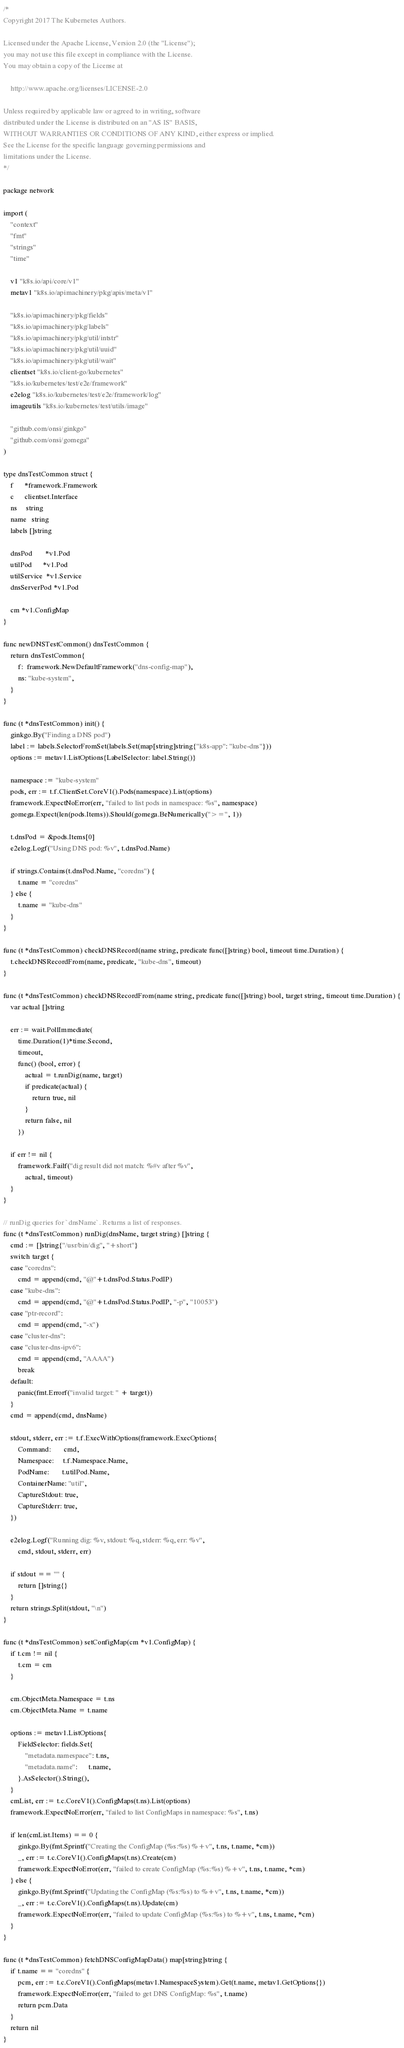Convert code to text. <code><loc_0><loc_0><loc_500><loc_500><_Go_>/*
Copyright 2017 The Kubernetes Authors.

Licensed under the Apache License, Version 2.0 (the "License");
you may not use this file except in compliance with the License.
You may obtain a copy of the License at

    http://www.apache.org/licenses/LICENSE-2.0

Unless required by applicable law or agreed to in writing, software
distributed under the License is distributed on an "AS IS" BASIS,
WITHOUT WARRANTIES OR CONDITIONS OF ANY KIND, either express or implied.
See the License for the specific language governing permissions and
limitations under the License.
*/

package network

import (
	"context"
	"fmt"
	"strings"
	"time"

	v1 "k8s.io/api/core/v1"
	metav1 "k8s.io/apimachinery/pkg/apis/meta/v1"

	"k8s.io/apimachinery/pkg/fields"
	"k8s.io/apimachinery/pkg/labels"
	"k8s.io/apimachinery/pkg/util/intstr"
	"k8s.io/apimachinery/pkg/util/uuid"
	"k8s.io/apimachinery/pkg/util/wait"
	clientset "k8s.io/client-go/kubernetes"
	"k8s.io/kubernetes/test/e2e/framework"
	e2elog "k8s.io/kubernetes/test/e2e/framework/log"
	imageutils "k8s.io/kubernetes/test/utils/image"

	"github.com/onsi/ginkgo"
	"github.com/onsi/gomega"
)

type dnsTestCommon struct {
	f      *framework.Framework
	c      clientset.Interface
	ns     string
	name   string
	labels []string

	dnsPod       *v1.Pod
	utilPod      *v1.Pod
	utilService  *v1.Service
	dnsServerPod *v1.Pod

	cm *v1.ConfigMap
}

func newDNSTestCommon() dnsTestCommon {
	return dnsTestCommon{
		f:  framework.NewDefaultFramework("dns-config-map"),
		ns: "kube-system",
	}
}

func (t *dnsTestCommon) init() {
	ginkgo.By("Finding a DNS pod")
	label := labels.SelectorFromSet(labels.Set(map[string]string{"k8s-app": "kube-dns"}))
	options := metav1.ListOptions{LabelSelector: label.String()}

	namespace := "kube-system"
	pods, err := t.f.ClientSet.CoreV1().Pods(namespace).List(options)
	framework.ExpectNoError(err, "failed to list pods in namespace: %s", namespace)
	gomega.Expect(len(pods.Items)).Should(gomega.BeNumerically(">=", 1))

	t.dnsPod = &pods.Items[0]
	e2elog.Logf("Using DNS pod: %v", t.dnsPod.Name)

	if strings.Contains(t.dnsPod.Name, "coredns") {
		t.name = "coredns"
	} else {
		t.name = "kube-dns"
	}
}

func (t *dnsTestCommon) checkDNSRecord(name string, predicate func([]string) bool, timeout time.Duration) {
	t.checkDNSRecordFrom(name, predicate, "kube-dns", timeout)
}

func (t *dnsTestCommon) checkDNSRecordFrom(name string, predicate func([]string) bool, target string, timeout time.Duration) {
	var actual []string

	err := wait.PollImmediate(
		time.Duration(1)*time.Second,
		timeout,
		func() (bool, error) {
			actual = t.runDig(name, target)
			if predicate(actual) {
				return true, nil
			}
			return false, nil
		})

	if err != nil {
		framework.Failf("dig result did not match: %#v after %v",
			actual, timeout)
	}
}

// runDig queries for `dnsName`. Returns a list of responses.
func (t *dnsTestCommon) runDig(dnsName, target string) []string {
	cmd := []string{"/usr/bin/dig", "+short"}
	switch target {
	case "coredns":
		cmd = append(cmd, "@"+t.dnsPod.Status.PodIP)
	case "kube-dns":
		cmd = append(cmd, "@"+t.dnsPod.Status.PodIP, "-p", "10053")
	case "ptr-record":
		cmd = append(cmd, "-x")
	case "cluster-dns":
	case "cluster-dns-ipv6":
		cmd = append(cmd, "AAAA")
		break
	default:
		panic(fmt.Errorf("invalid target: " + target))
	}
	cmd = append(cmd, dnsName)

	stdout, stderr, err := t.f.ExecWithOptions(framework.ExecOptions{
		Command:       cmd,
		Namespace:     t.f.Namespace.Name,
		PodName:       t.utilPod.Name,
		ContainerName: "util",
		CaptureStdout: true,
		CaptureStderr: true,
	})

	e2elog.Logf("Running dig: %v, stdout: %q, stderr: %q, err: %v",
		cmd, stdout, stderr, err)

	if stdout == "" {
		return []string{}
	}
	return strings.Split(stdout, "\n")
}

func (t *dnsTestCommon) setConfigMap(cm *v1.ConfigMap) {
	if t.cm != nil {
		t.cm = cm
	}

	cm.ObjectMeta.Namespace = t.ns
	cm.ObjectMeta.Name = t.name

	options := metav1.ListOptions{
		FieldSelector: fields.Set{
			"metadata.namespace": t.ns,
			"metadata.name":      t.name,
		}.AsSelector().String(),
	}
	cmList, err := t.c.CoreV1().ConfigMaps(t.ns).List(options)
	framework.ExpectNoError(err, "failed to list ConfigMaps in namespace: %s", t.ns)

	if len(cmList.Items) == 0 {
		ginkgo.By(fmt.Sprintf("Creating the ConfigMap (%s:%s) %+v", t.ns, t.name, *cm))
		_, err := t.c.CoreV1().ConfigMaps(t.ns).Create(cm)
		framework.ExpectNoError(err, "failed to create ConfigMap (%s:%s) %+v", t.ns, t.name, *cm)
	} else {
		ginkgo.By(fmt.Sprintf("Updating the ConfigMap (%s:%s) to %+v", t.ns, t.name, *cm))
		_, err := t.c.CoreV1().ConfigMaps(t.ns).Update(cm)
		framework.ExpectNoError(err, "failed to update ConfigMap (%s:%s) to %+v", t.ns, t.name, *cm)
	}
}

func (t *dnsTestCommon) fetchDNSConfigMapData() map[string]string {
	if t.name == "coredns" {
		pcm, err := t.c.CoreV1().ConfigMaps(metav1.NamespaceSystem).Get(t.name, metav1.GetOptions{})
		framework.ExpectNoError(err, "failed to get DNS ConfigMap: %s", t.name)
		return pcm.Data
	}
	return nil
}
</code> 